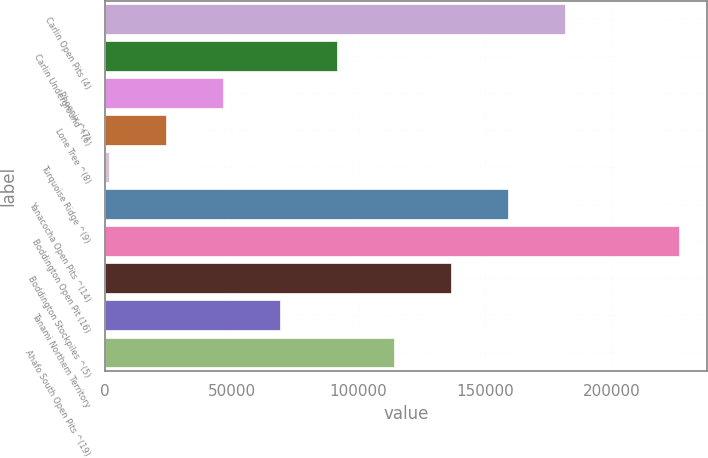<chart> <loc_0><loc_0><loc_500><loc_500><bar_chart><fcel>Carlin Open Pits (4)<fcel>Carlin Underground ^(6)<fcel>Phoenix ^(7)<fcel>Lone Tree ^(8)<fcel>Turquoise Ridge ^(9)<fcel>Yanacocha Open Pits ^(14)<fcel>Boddington Open Pit (16)<fcel>Boddington Stockpiles ^(5)<fcel>Tanami Northern Territory<fcel>Ahafo South Open Pits ^(19)<nl><fcel>181420<fcel>91460<fcel>46480<fcel>23990<fcel>1500<fcel>158930<fcel>226400<fcel>136440<fcel>68970<fcel>113950<nl></chart> 